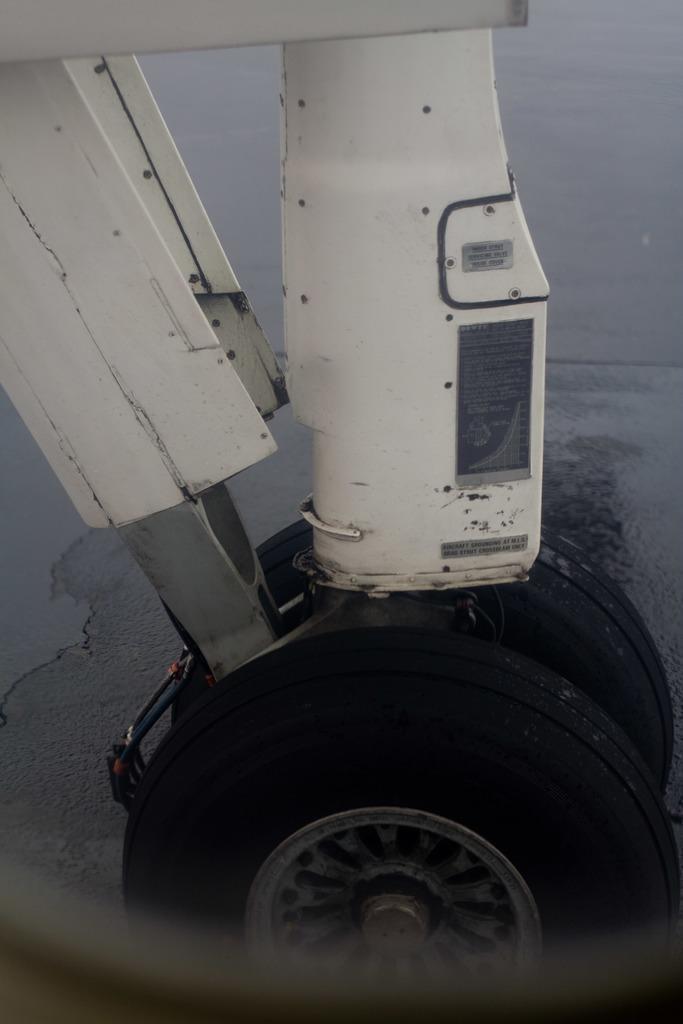Describe this image in one or two sentences. In this picture we can see wheels on the ground and metal objects. 